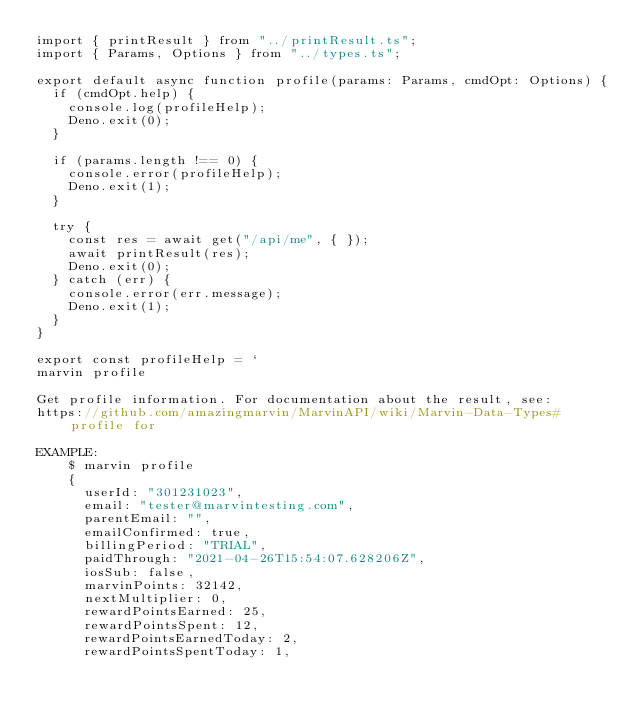<code> <loc_0><loc_0><loc_500><loc_500><_TypeScript_>import { printResult } from "../printResult.ts";
import { Params, Options } from "../types.ts";

export default async function profile(params: Params, cmdOpt: Options) {
  if (cmdOpt.help) {
    console.log(profileHelp);
    Deno.exit(0);
  }

  if (params.length !== 0) {
    console.error(profileHelp);
    Deno.exit(1);
  }

  try {
    const res = await get("/api/me", { });
    await printResult(res);
    Deno.exit(0);
  } catch (err) {
    console.error(err.message);
    Deno.exit(1);
  }
}

export const profileHelp = `
marvin profile

Get profile information. For documentation about the result, see:
https://github.com/amazingmarvin/MarvinAPI/wiki/Marvin-Data-Types#profile for

EXAMPLE:
    $ marvin profile
    {
      userId: "301231023",
      email: "tester@marvintesting.com",
      parentEmail: "",
      emailConfirmed: true,
      billingPeriod: "TRIAL",
      paidThrough: "2021-04-26T15:54:07.628206Z",
      iosSub: false,
      marvinPoints: 32142,
      nextMultiplier: 0,
      rewardPointsEarned: 25,
      rewardPointsSpent: 12,
      rewardPointsEarnedToday: 2,
      rewardPointsSpentToday: 1,</code> 